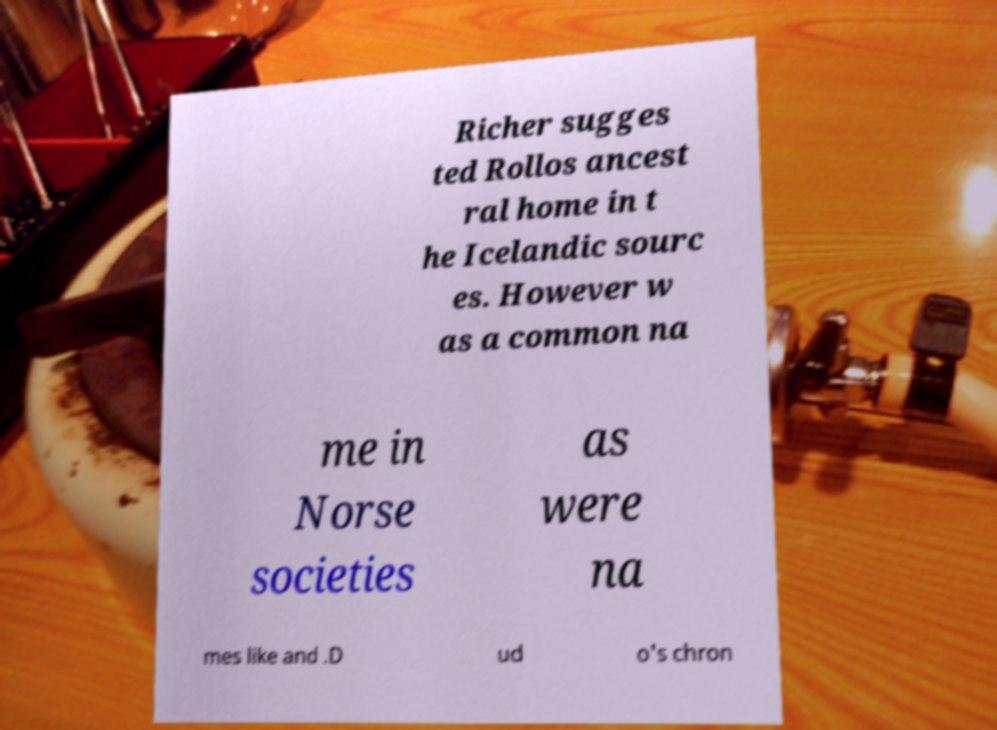Can you accurately transcribe the text from the provided image for me? Richer sugges ted Rollos ancest ral home in t he Icelandic sourc es. However w as a common na me in Norse societies as were na mes like and .D ud o's chron 